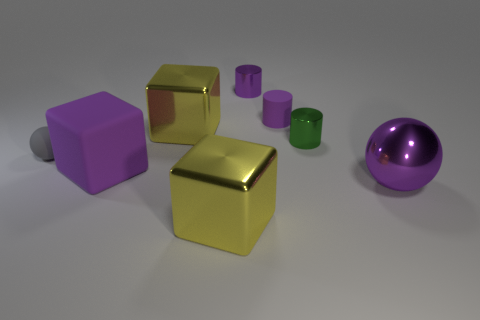There is a purple metal object that is to the left of the purple ball; what size is it?
Keep it short and to the point. Small. Is the color of the small metal cylinder that is behind the tiny green metallic object the same as the large metallic object that is right of the purple shiny cylinder?
Give a very brief answer. Yes. What is the ball behind the rubber cube that is on the left side of the large yellow metal thing that is behind the tiny green cylinder made of?
Your response must be concise. Rubber. Are there any green things that have the same size as the gray ball?
Offer a terse response. Yes. What material is the purple object that is the same size as the purple rubber cylinder?
Your answer should be very brief. Metal. What is the shape of the matte thing in front of the gray rubber sphere?
Ensure brevity in your answer.  Cube. Is the material of the cube that is behind the tiny gray thing the same as the small gray ball that is left of the metal ball?
Offer a very short reply. No. How many large purple rubber objects are the same shape as the tiny purple metallic object?
Your answer should be compact. 0. There is a big cube that is the same color as the big shiny sphere; what is it made of?
Your response must be concise. Rubber. What number of things are small purple rubber objects or small gray spheres that are behind the purple metal sphere?
Provide a succinct answer. 2. 